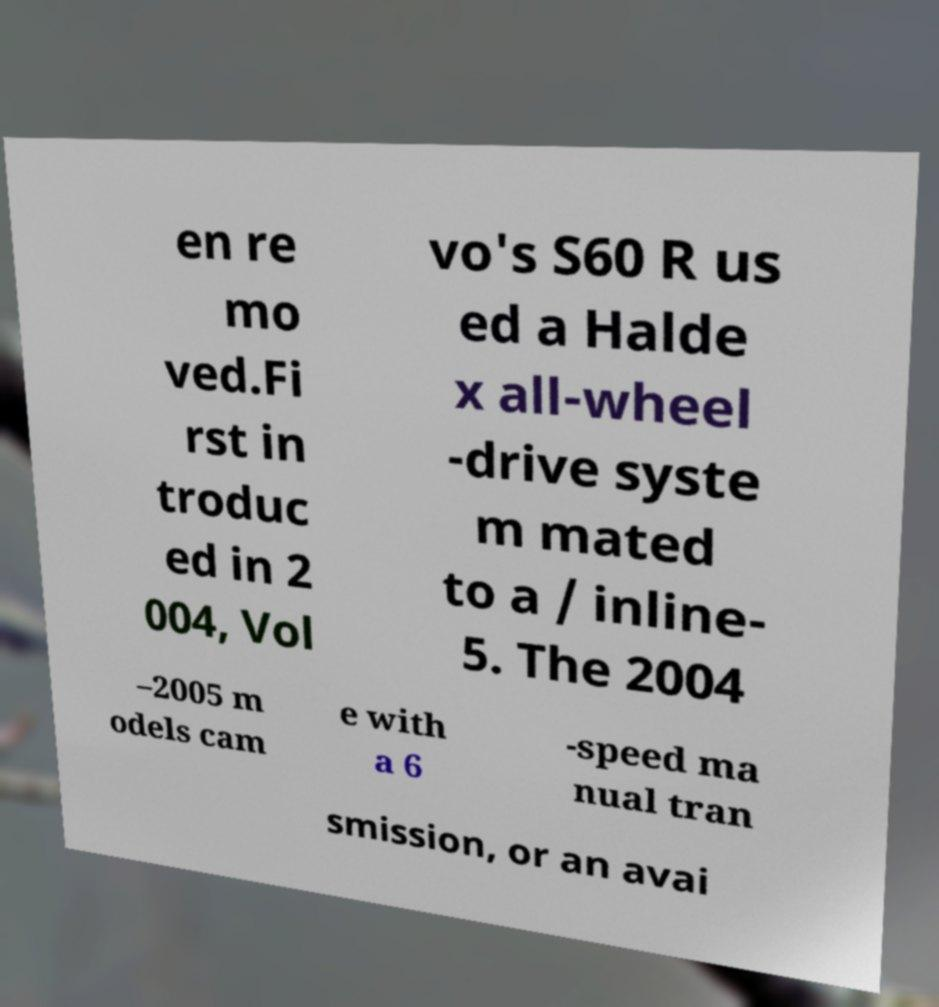Please identify and transcribe the text found in this image. en re mo ved.Fi rst in troduc ed in 2 004, Vol vo's S60 R us ed a Halde x all-wheel -drive syste m mated to a / inline- 5. The 2004 –2005 m odels cam e with a 6 -speed ma nual tran smission, or an avai 